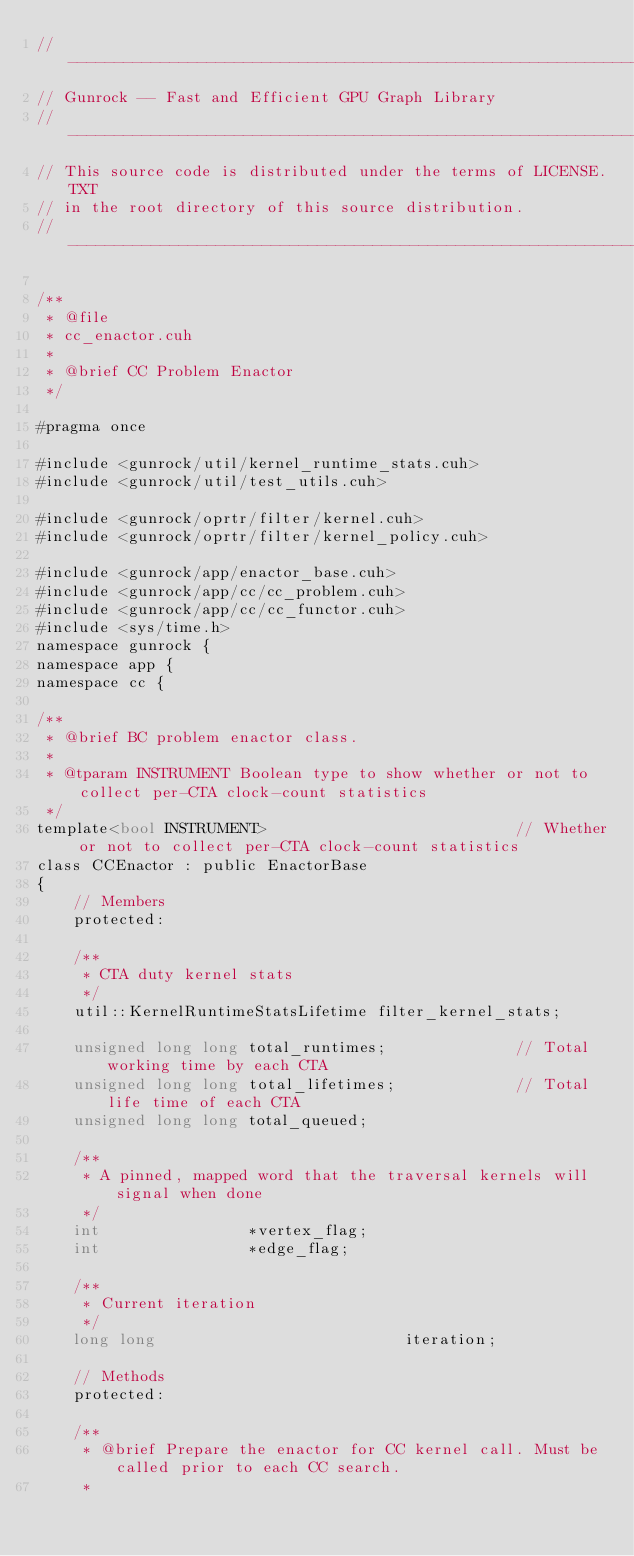<code> <loc_0><loc_0><loc_500><loc_500><_Cuda_>// ----------------------------------------------------------------
// Gunrock -- Fast and Efficient GPU Graph Library
// ----------------------------------------------------------------
// This source code is distributed under the terms of LICENSE.TXT
// in the root directory of this source distribution.
// ----------------------------------------------------------------

/**
 * @file
 * cc_enactor.cuh
 *
 * @brief CC Problem Enactor
 */

#pragma once

#include <gunrock/util/kernel_runtime_stats.cuh>
#include <gunrock/util/test_utils.cuh>

#include <gunrock/oprtr/filter/kernel.cuh>
#include <gunrock/oprtr/filter/kernel_policy.cuh>

#include <gunrock/app/enactor_base.cuh>
#include <gunrock/app/cc/cc_problem.cuh>
#include <gunrock/app/cc/cc_functor.cuh>
#include <sys/time.h>
namespace gunrock {
namespace app {
namespace cc {

/**
 * @brief BC problem enactor class.
 *
 * @tparam INSTRUMENT Boolean type to show whether or not to collect per-CTA clock-count statistics
 */
template<bool INSTRUMENT>                           // Whether or not to collect per-CTA clock-count statistics
class CCEnactor : public EnactorBase
{
    // Members
    protected:

    /**
     * CTA duty kernel stats
     */
    util::KernelRuntimeStatsLifetime filter_kernel_stats;

    unsigned long long total_runtimes;              // Total working time by each CTA
    unsigned long long total_lifetimes;             // Total life time of each CTA
    unsigned long long total_queued;

    /**
     * A pinned, mapped word that the traversal kernels will signal when done
     */
    int                *vertex_flag;
    int                *edge_flag;

    /**
     * Current iteration
     */
    long long                           iteration;

    // Methods
    protected:

    /**
     * @brief Prepare the enactor for CC kernel call. Must be called prior to each CC search.
     *</code> 